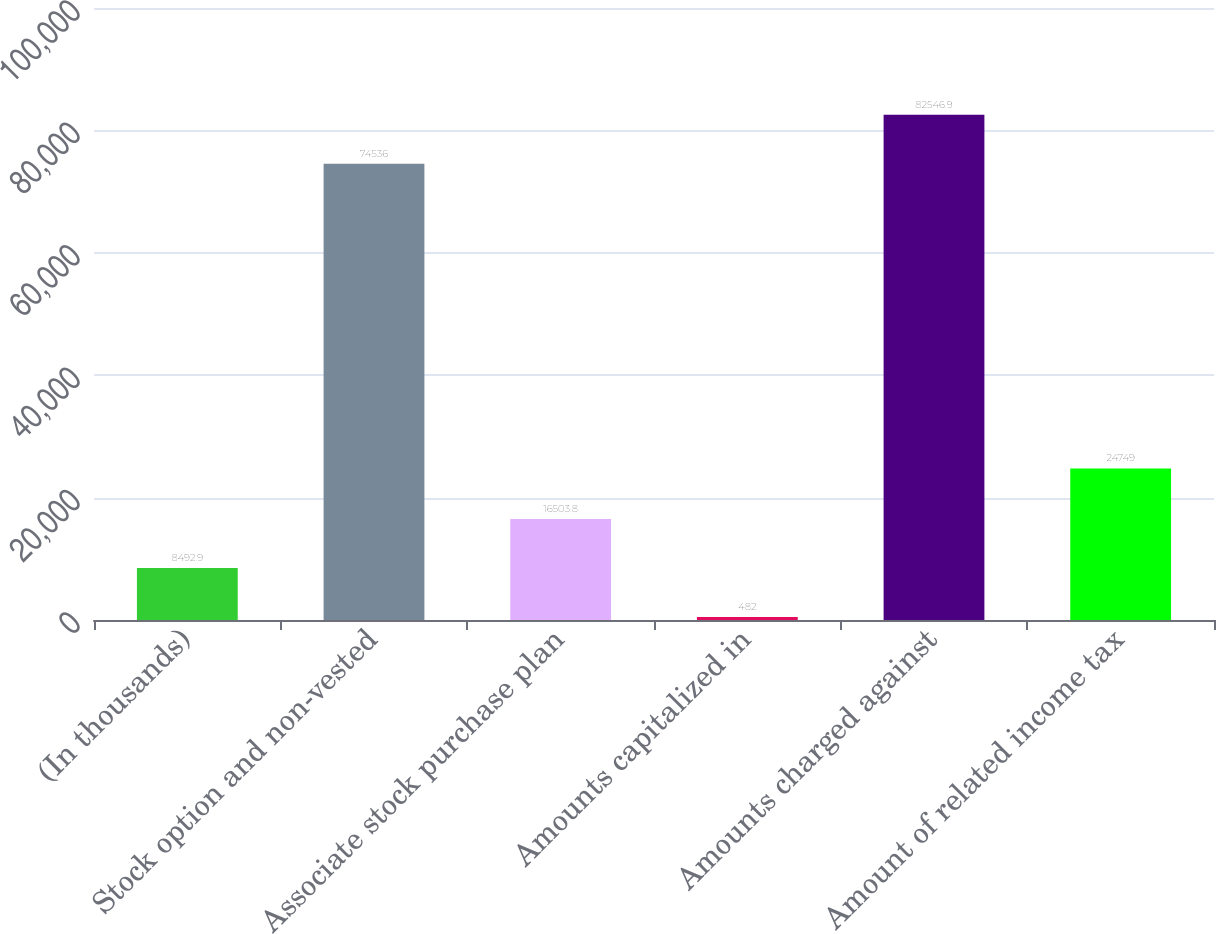Convert chart. <chart><loc_0><loc_0><loc_500><loc_500><bar_chart><fcel>(In thousands)<fcel>Stock option and non-vested<fcel>Associate stock purchase plan<fcel>Amounts capitalized in<fcel>Amounts charged against<fcel>Amount of related income tax<nl><fcel>8492.9<fcel>74536<fcel>16503.8<fcel>482<fcel>82546.9<fcel>24749<nl></chart> 